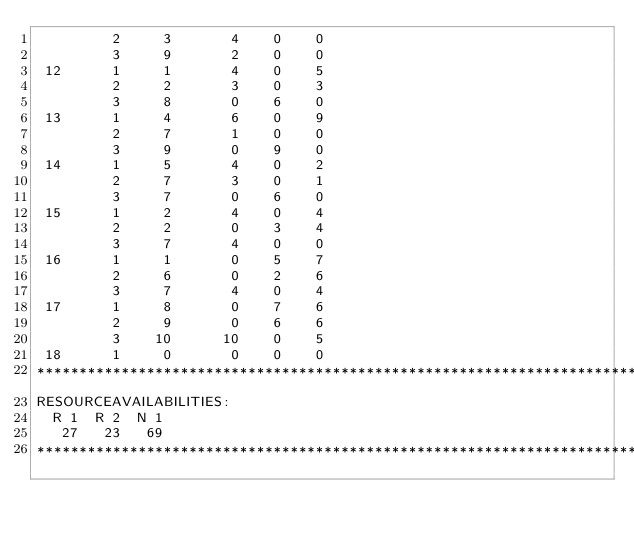<code> <loc_0><loc_0><loc_500><loc_500><_ObjectiveC_>         2     3       4    0    0
         3     9       2    0    0
 12      1     1       4    0    5
         2     2       3    0    3
         3     8       0    6    0
 13      1     4       6    0    9
         2     7       1    0    0
         3     9       0    9    0
 14      1     5       4    0    2
         2     7       3    0    1
         3     7       0    6    0
 15      1     2       4    0    4
         2     2       0    3    4
         3     7       4    0    0
 16      1     1       0    5    7
         2     6       0    2    6
         3     7       4    0    4
 17      1     8       0    7    6
         2     9       0    6    6
         3    10      10    0    5
 18      1     0       0    0    0
************************************************************************
RESOURCEAVAILABILITIES:
  R 1  R 2  N 1
   27   23   69
************************************************************************
</code> 